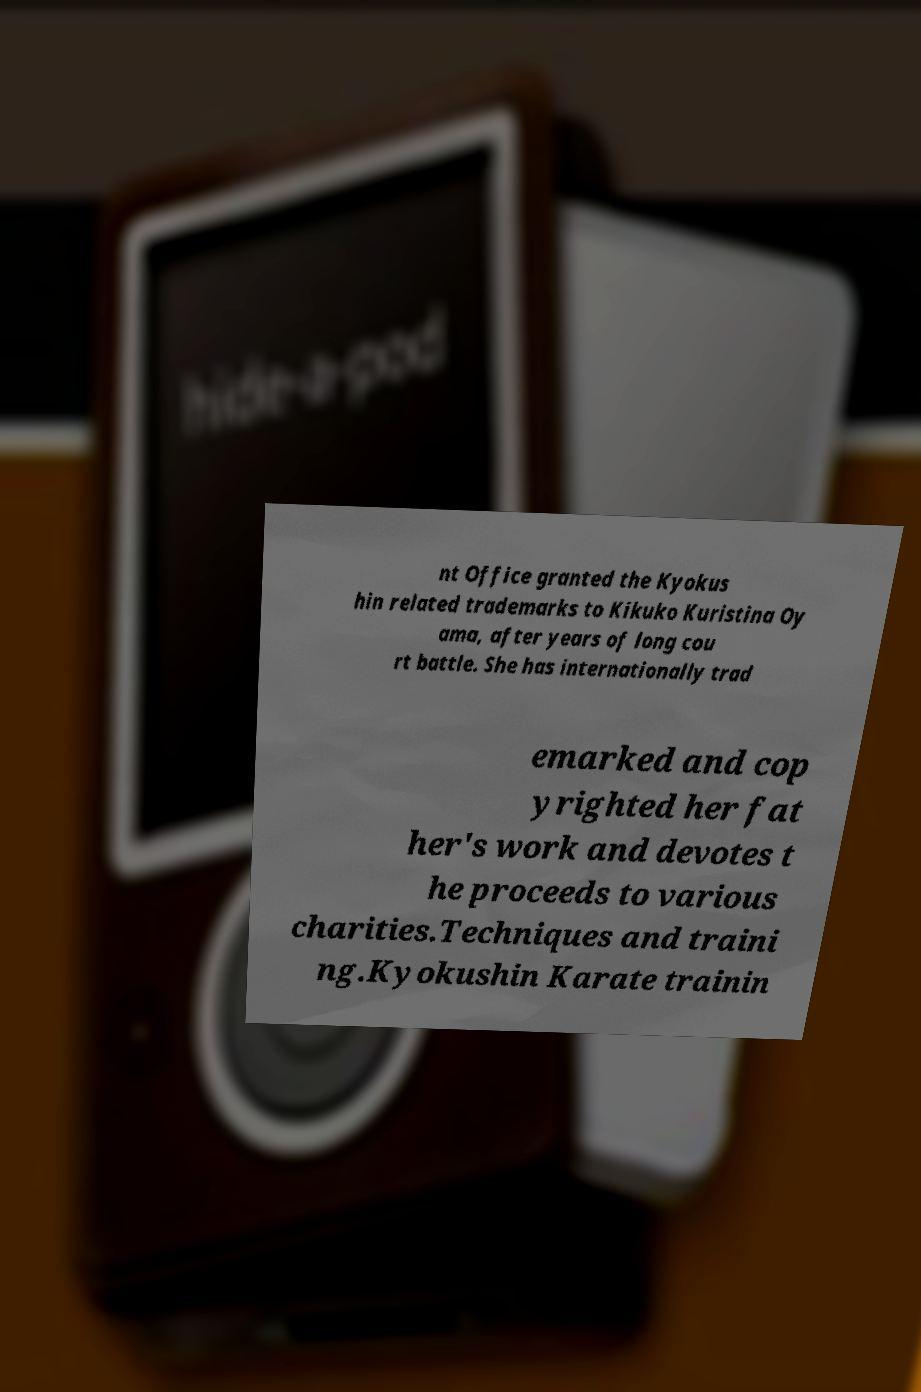Could you assist in decoding the text presented in this image and type it out clearly? nt Office granted the Kyokus hin related trademarks to Kikuko Kuristina Oy ama, after years of long cou rt battle. She has internationally trad emarked and cop yrighted her fat her's work and devotes t he proceeds to various charities.Techniques and traini ng.Kyokushin Karate trainin 